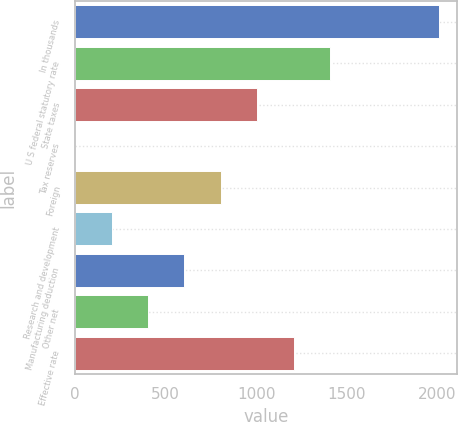<chart> <loc_0><loc_0><loc_500><loc_500><bar_chart><fcel>In thousands<fcel>U S federal statutory rate<fcel>State taxes<fcel>Tax reserves<fcel>Foreign<fcel>Research and development<fcel>Manufacturing deduction<fcel>Other net<fcel>Effective rate<nl><fcel>2011<fcel>1407.85<fcel>1005.75<fcel>0.5<fcel>804.7<fcel>201.55<fcel>603.65<fcel>402.6<fcel>1206.8<nl></chart> 